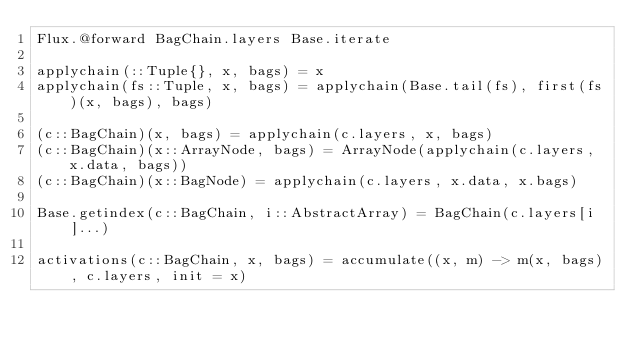<code> <loc_0><loc_0><loc_500><loc_500><_Julia_>Flux.@forward BagChain.layers Base.iterate

applychain(::Tuple{}, x, bags) = x
applychain(fs::Tuple, x, bags) = applychain(Base.tail(fs), first(fs)(x, bags), bags)

(c::BagChain)(x, bags) = applychain(c.layers, x, bags)
(c::BagChain)(x::ArrayNode, bags) = ArrayNode(applychain(c.layers, x.data, bags))
(c::BagChain)(x::BagNode) = applychain(c.layers, x.data, x.bags)

Base.getindex(c::BagChain, i::AbstractArray) = BagChain(c.layers[i]...)

activations(c::BagChain, x, bags) = accumulate((x, m) -> m(x, bags), c.layers, init = x)
</code> 